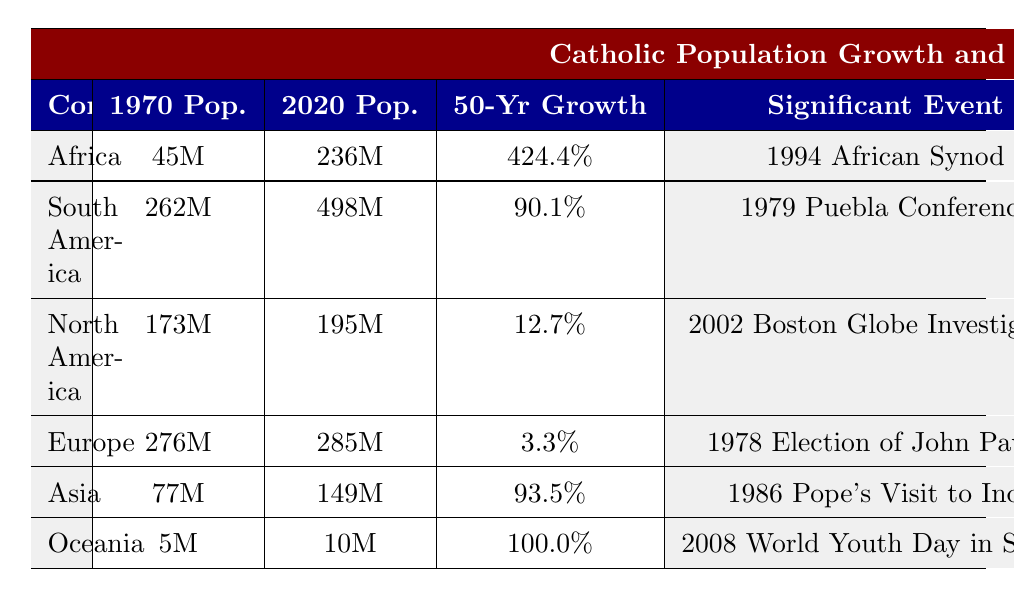What was the Catholic population in Africa in 1970? The table lists the Catholic population in Africa for the year 1970, which is 45 million.
Answer: 45 million What is the 50-year growth rate for South America? The table directly shows that South America's 50-year growth rate is 90.1%.
Answer: 90.1% Which continent experienced the lowest growth rate? By comparing the growth rates, Europe has the lowest at 3.3%.
Answer: Europe What is the difference in Catholic population between 1970 and 2020 in North America? The population in North America grew from 173 million in 1970 to 195 million in 2020. The difference is 195 million - 173 million = 22 million.
Answer: 22 million Did Asia have a higher growth rate than South America over the last 50 years? Asia had a growth rate of 93.5% while South America had 90.1%, meaning Asia's growth rate is higher.
Answer: Yes What is the total Catholic population across all continents in 2020? To find the total, we sum the 2020 populations: 236M (Africa) + 498M (South America) + 195M (North America) + 285M (Europe) + 149M (Asia) + 10M (Oceania) = 1373 million.
Answer: 1373 million Which significant event is associated with Oceania? The significant event listed for Oceania is the 2008 World Youth Day in Sydney.
Answer: 2008 World Youth Day in Sydney What major challenge is listed for Africa? The table points out that the major challenge for Africa is interfaith dialogue.
Answer: Interfaith dialogue Which continent has the same notable Catholic figure as the Vatican focus area of ecumenism? The notable figure for North America is Cardinal Timothy Dolan, associated with the Vatican focus area of ecumenism.
Answer: North America What is the growth rate difference between Africa and Europe? Africa's growth rate is 424.4% while Europe's is 3.3%. The difference is 424.4% - 3.3% = 421.1%.
Answer: 421.1% Which continent had the largest increase in Catholic population from 1970 to 2020? By comparing the increases, Africa shows an increase of 191 million (236 million - 45 million), which is the largest.
Answer: Africa 